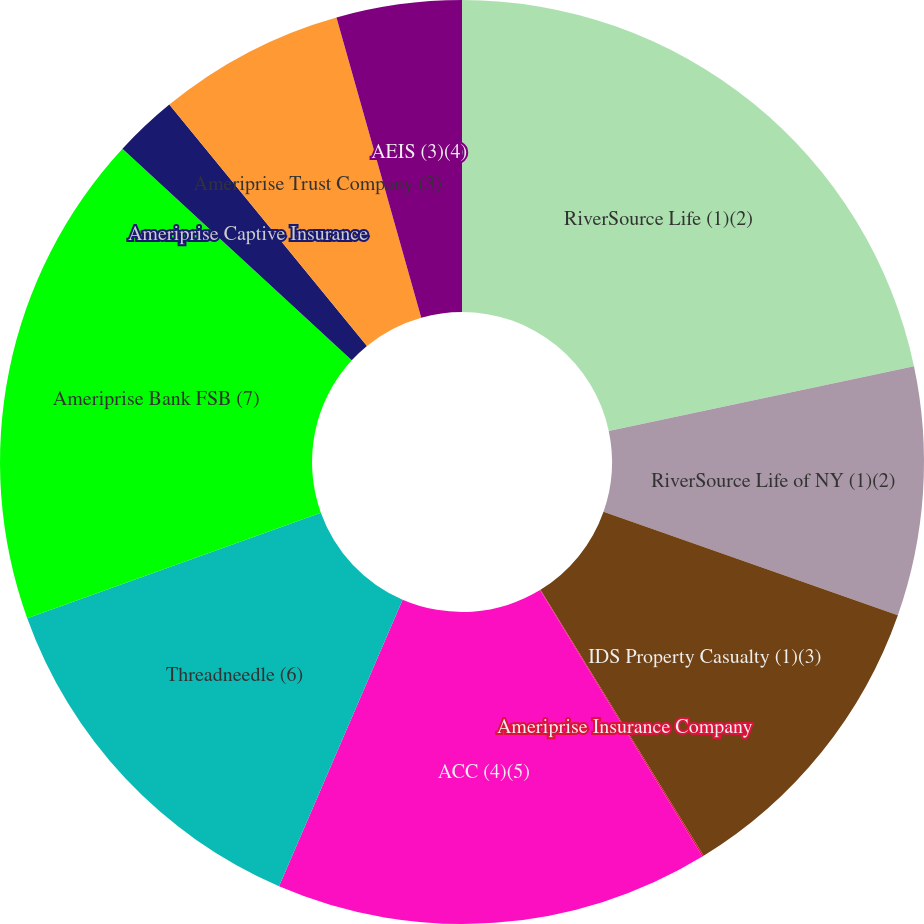<chart> <loc_0><loc_0><loc_500><loc_500><pie_chart><fcel>RiverSource Life (1)(2)<fcel>RiverSource Life of NY (1)(2)<fcel>IDS Property Casualty (1)(3)<fcel>Ameriprise Insurance Company<fcel>ACC (4)(5)<fcel>Threadneedle (6)<fcel>Ameriprise Bank FSB (7)<fcel>Ameriprise Captive Insurance<fcel>Ameriprise Trust Company (3)<fcel>AEIS (3)(4)<nl><fcel>21.68%<fcel>8.7%<fcel>10.86%<fcel>0.05%<fcel>15.19%<fcel>13.03%<fcel>17.35%<fcel>2.22%<fcel>6.54%<fcel>4.38%<nl></chart> 